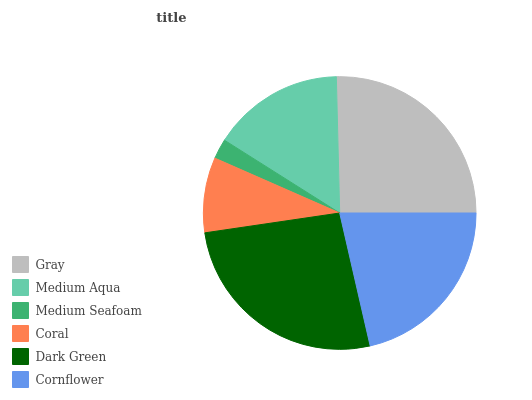Is Medium Seafoam the minimum?
Answer yes or no. Yes. Is Dark Green the maximum?
Answer yes or no. Yes. Is Medium Aqua the minimum?
Answer yes or no. No. Is Medium Aqua the maximum?
Answer yes or no. No. Is Gray greater than Medium Aqua?
Answer yes or no. Yes. Is Medium Aqua less than Gray?
Answer yes or no. Yes. Is Medium Aqua greater than Gray?
Answer yes or no. No. Is Gray less than Medium Aqua?
Answer yes or no. No. Is Cornflower the high median?
Answer yes or no. Yes. Is Medium Aqua the low median?
Answer yes or no. Yes. Is Gray the high median?
Answer yes or no. No. Is Gray the low median?
Answer yes or no. No. 